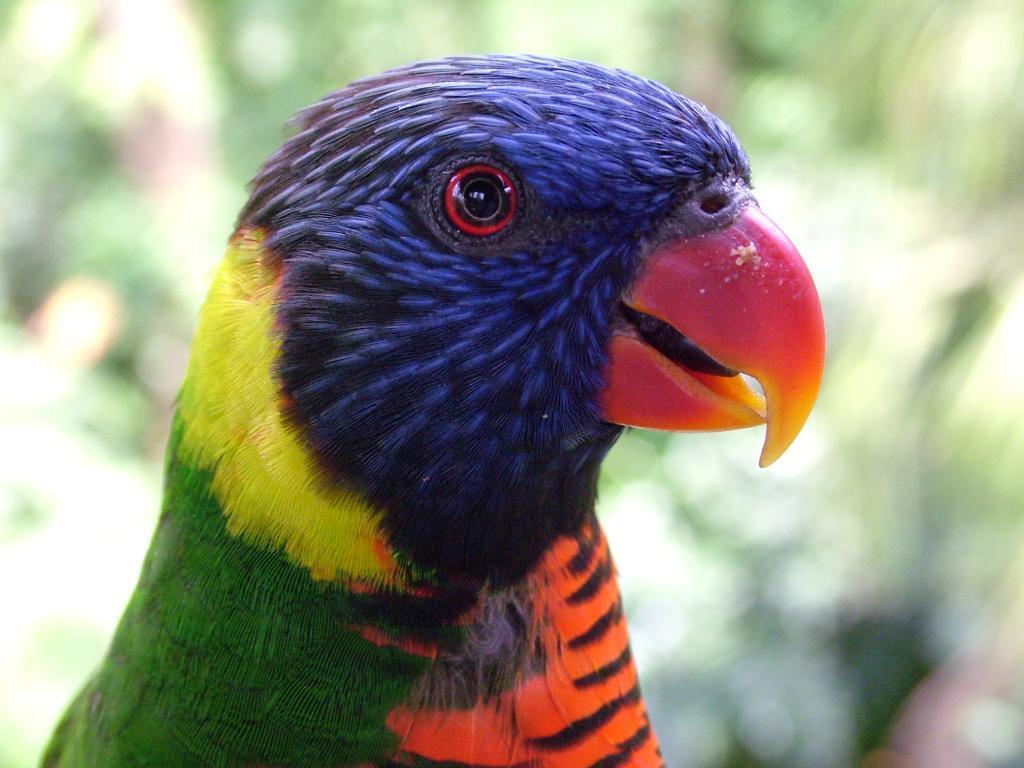In one or two sentences, can you explain what this image depicts? In this image we can see a bird. 